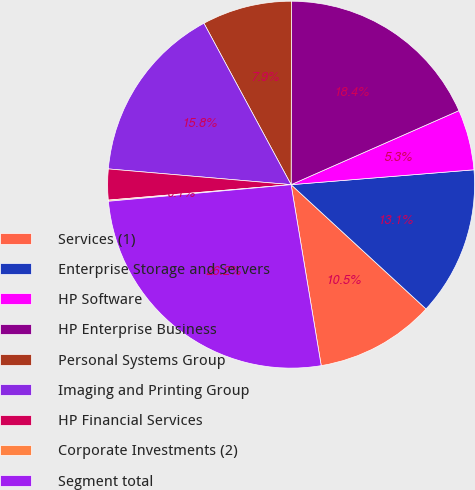Convert chart to OTSL. <chart><loc_0><loc_0><loc_500><loc_500><pie_chart><fcel>Services (1)<fcel>Enterprise Storage and Servers<fcel>HP Software<fcel>HP Enterprise Business<fcel>Personal Systems Group<fcel>Imaging and Printing Group<fcel>HP Financial Services<fcel>Corporate Investments (2)<fcel>Segment total<nl><fcel>10.53%<fcel>13.14%<fcel>5.32%<fcel>18.35%<fcel>7.92%<fcel>15.75%<fcel>2.71%<fcel>0.1%<fcel>26.18%<nl></chart> 